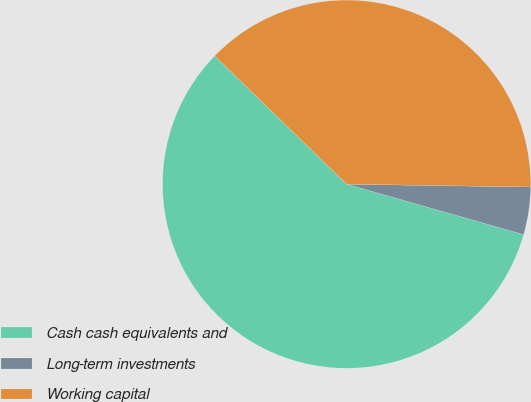Convert chart to OTSL. <chart><loc_0><loc_0><loc_500><loc_500><pie_chart><fcel>Cash cash equivalents and<fcel>Long-term investments<fcel>Working capital<nl><fcel>57.86%<fcel>4.17%<fcel>37.97%<nl></chart> 